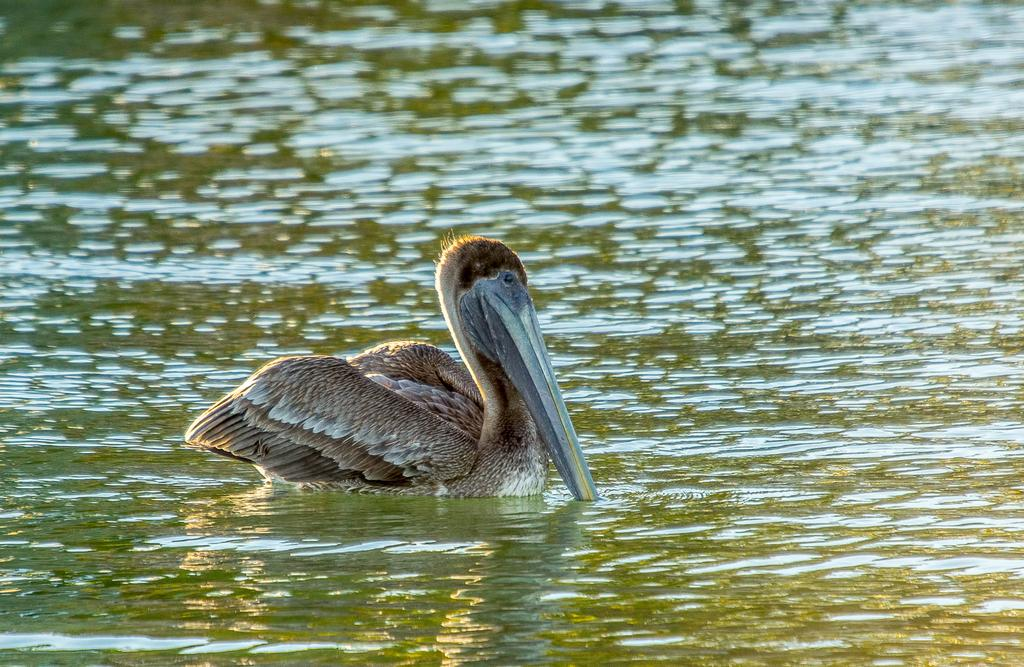What type of animal is in the image? There is a bird in the image. Where is the bird located? The bird is on the water. What type of rake is being used to stir the stew in the image? There is no rake or stew present in the image; it features a bird on the water. 